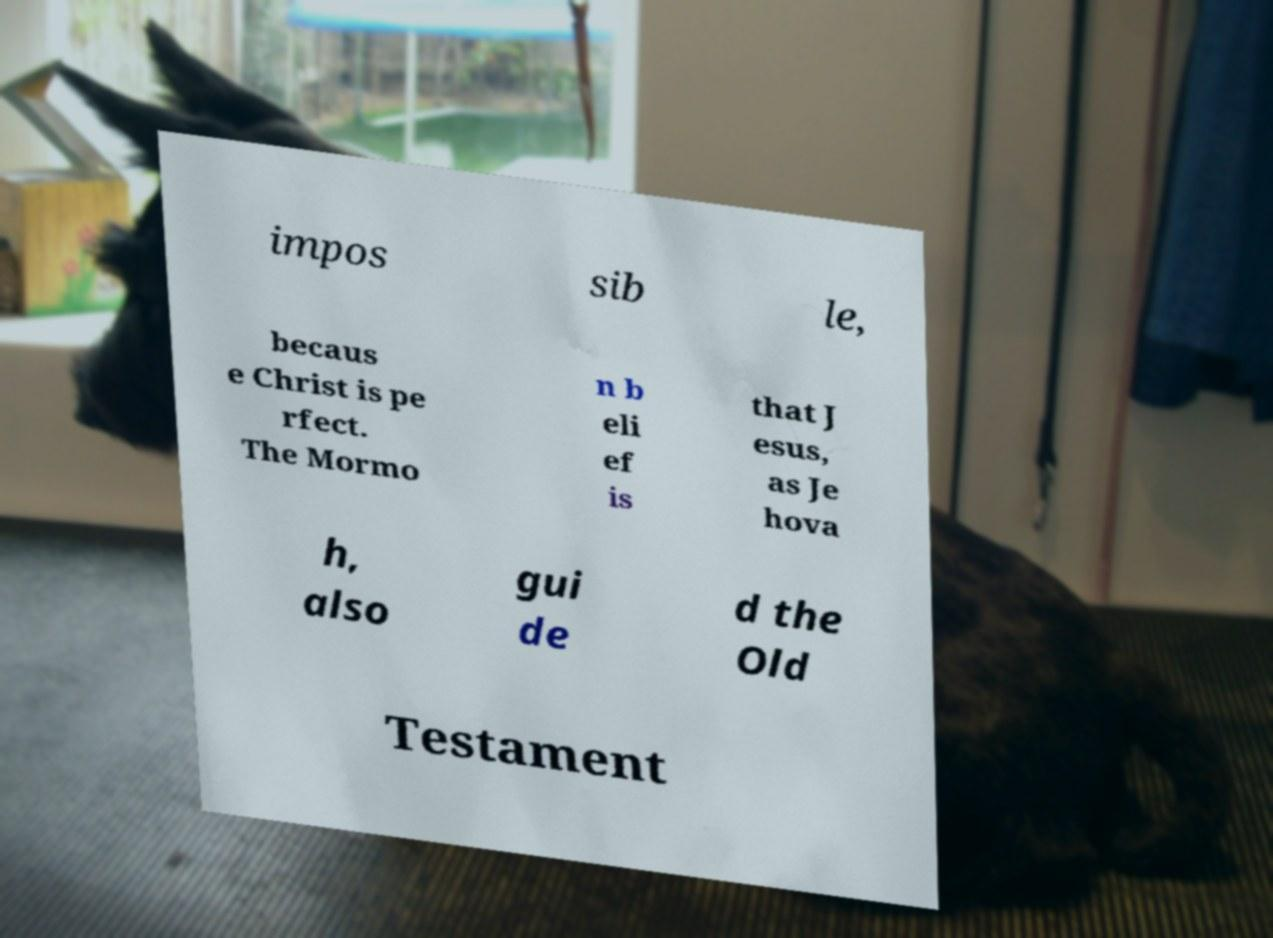I need the written content from this picture converted into text. Can you do that? impos sib le, becaus e Christ is pe rfect. The Mormo n b eli ef is that J esus, as Je hova h, also gui de d the Old Testament 